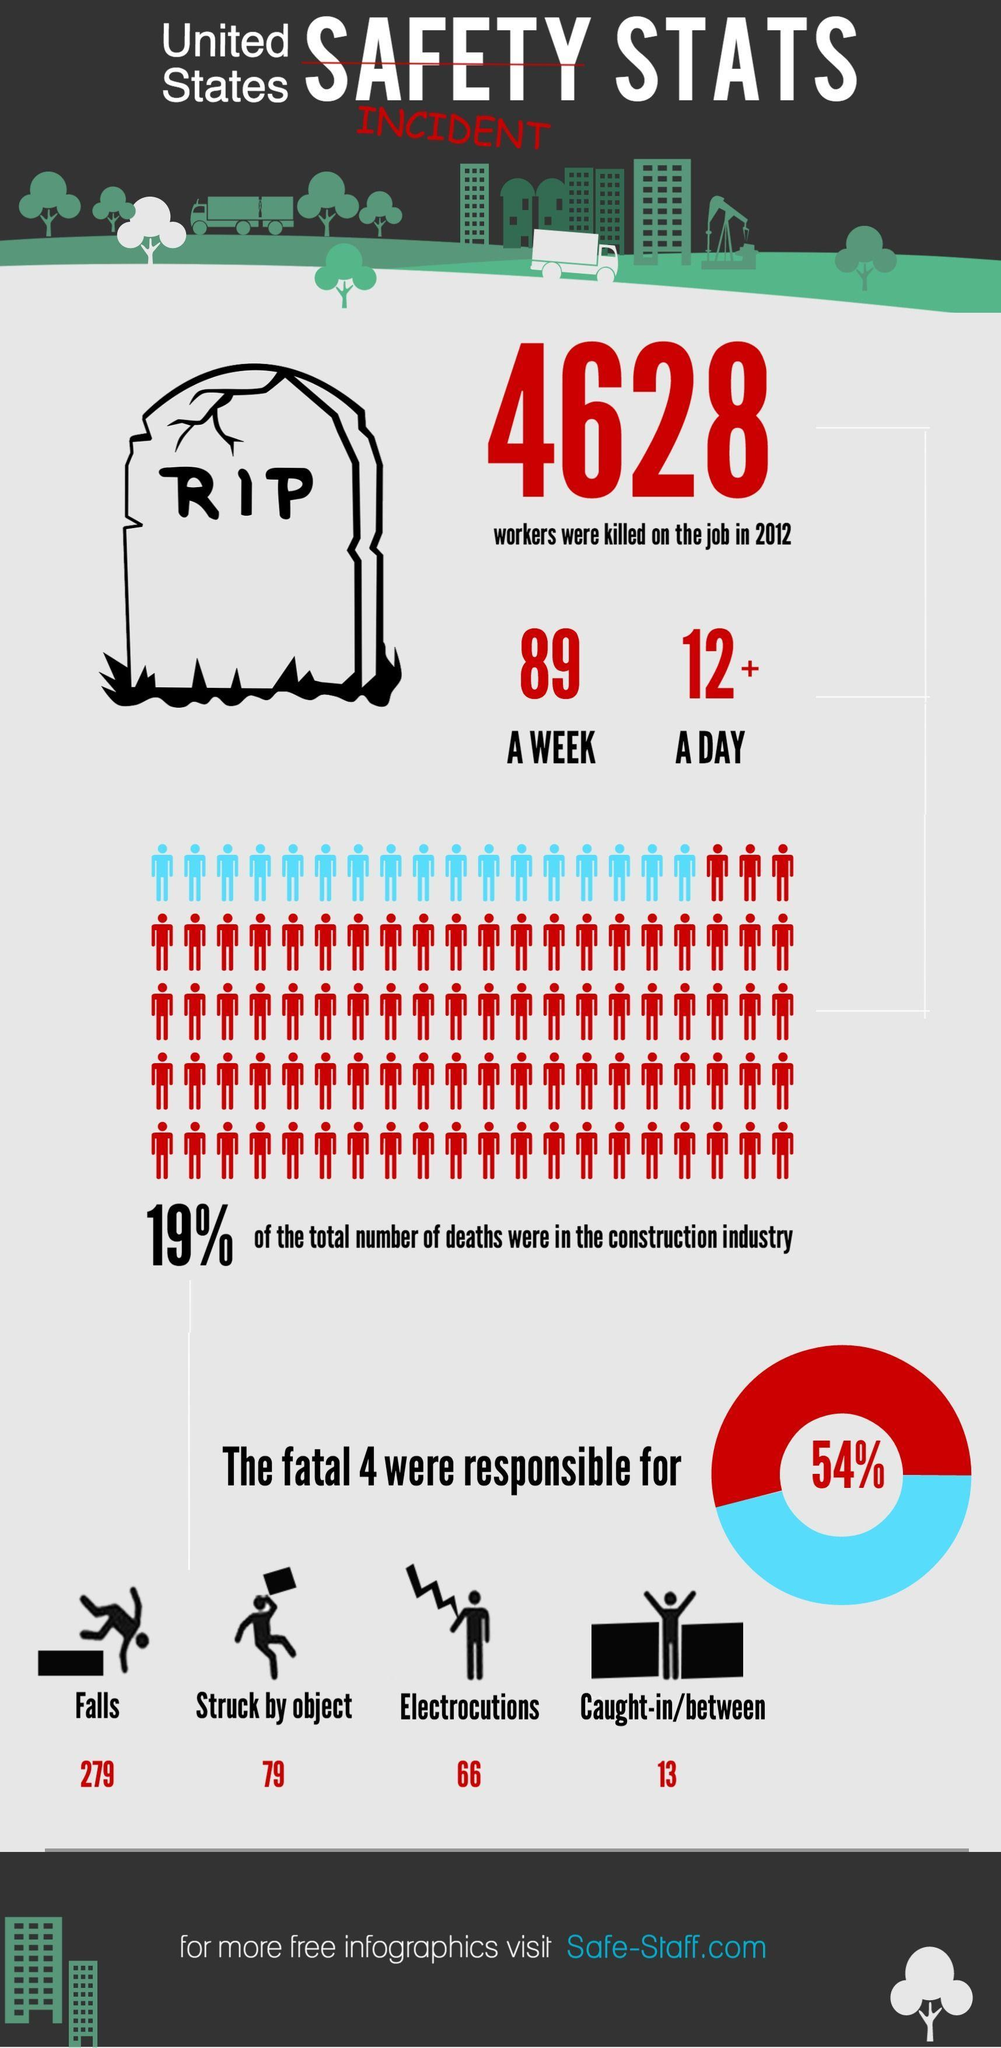How many workers got killed in a week?
Answer the question with a short phrase. 89 How many workers got struck by object? 79 How many workers got killed in a day? 12+ How many workers got Electrocutions? 66 What percentage of workers death were not in the construction field? 81 How many workers get killed through falls? 279 How many workers caught in between? 13 